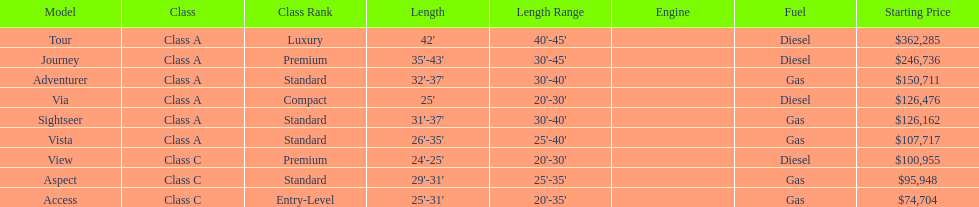Is the vista more than the aspect? Yes. 